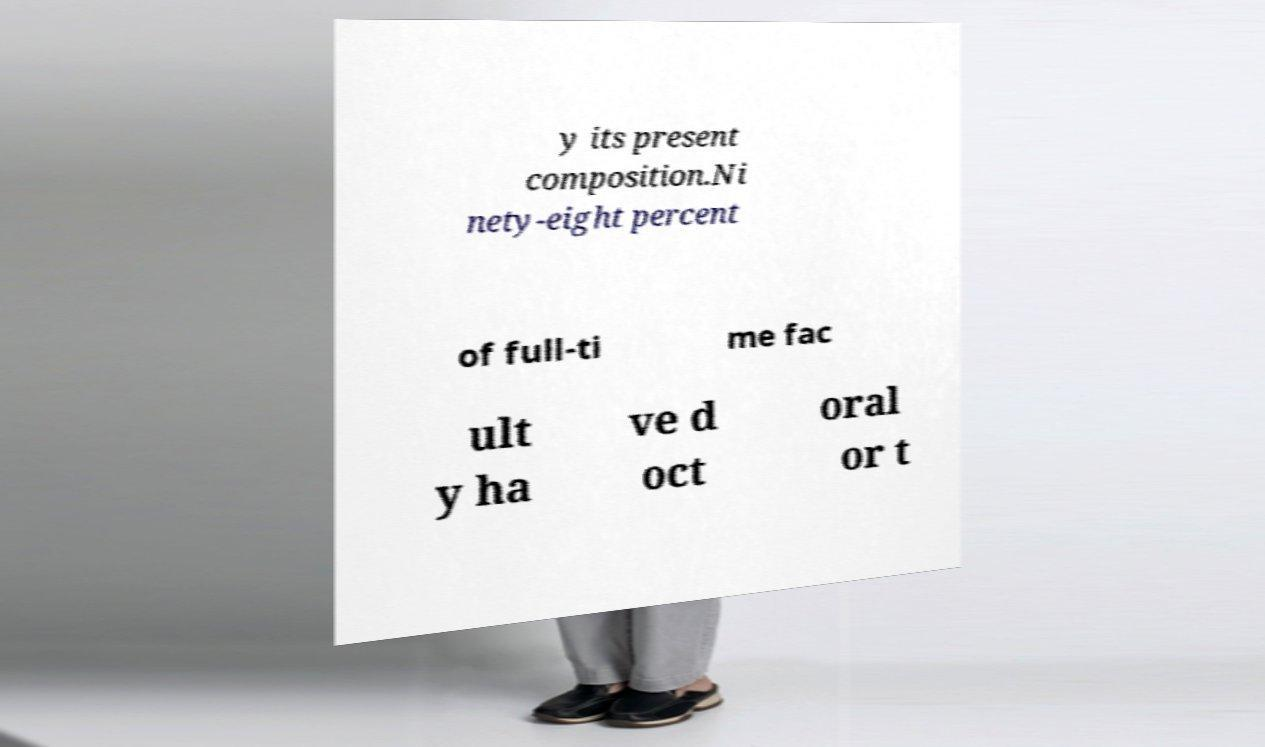Could you assist in decoding the text presented in this image and type it out clearly? y its present composition.Ni nety-eight percent of full-ti me fac ult y ha ve d oct oral or t 